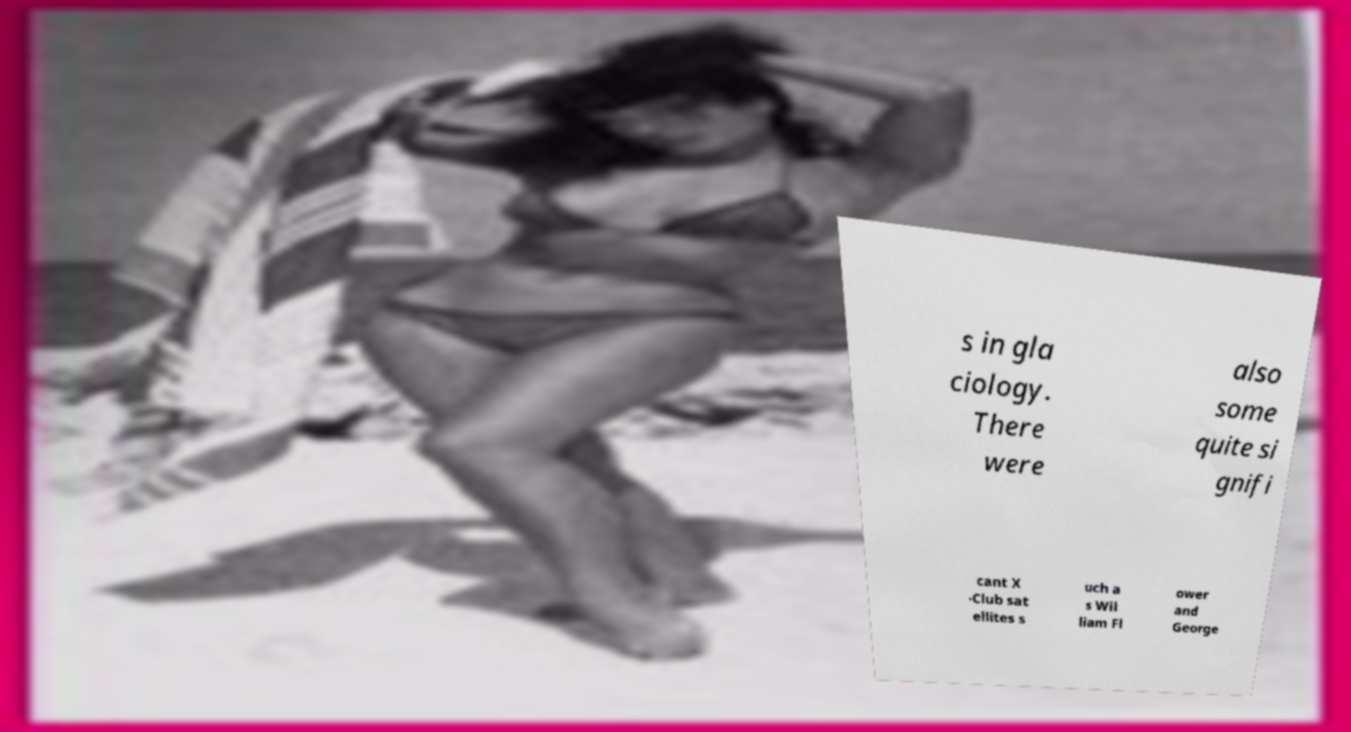Can you accurately transcribe the text from the provided image for me? s in gla ciology. There were also some quite si gnifi cant X -Club sat ellites s uch a s Wil liam Fl ower and George 